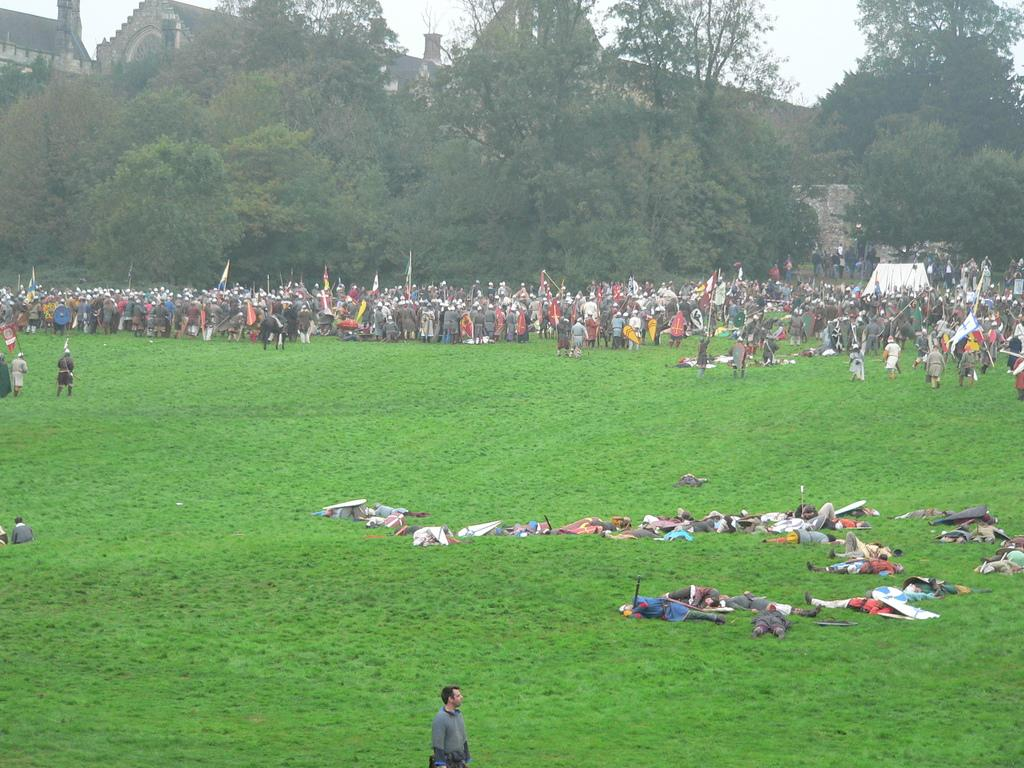What can be seen in the image? There are people standing in the image. Where are the people located in relation to the image? There are people standing in the background of the image. What type of vegetation is present in the image? There are trees in the image. What type of structure can be seen in the image? There is a building in the image. What is the condition of the sky in the image? The sky is clear in the image. Can you see any quicksand in the image? No, there is no quicksand present in the image. What type of space is visible in the image? The image does not depict any space; it is a ground-level scene with people, trees, a building, and a clear sky. 